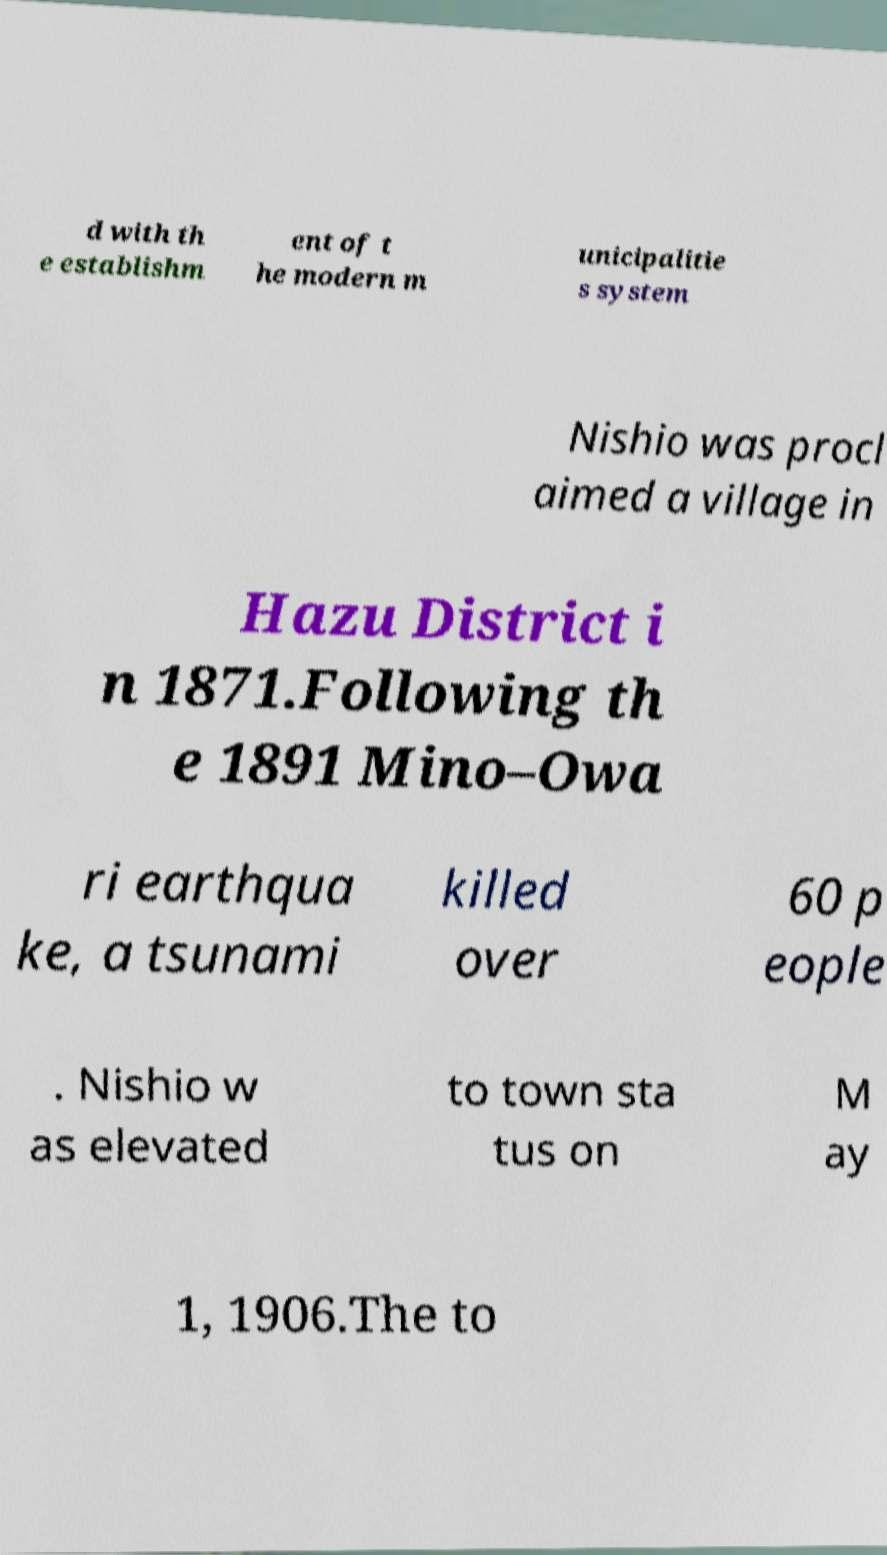Can you read and provide the text displayed in the image?This photo seems to have some interesting text. Can you extract and type it out for me? d with th e establishm ent of t he modern m unicipalitie s system Nishio was procl aimed a village in Hazu District i n 1871.Following th e 1891 Mino–Owa ri earthqua ke, a tsunami killed over 60 p eople . Nishio w as elevated to town sta tus on M ay 1, 1906.The to 